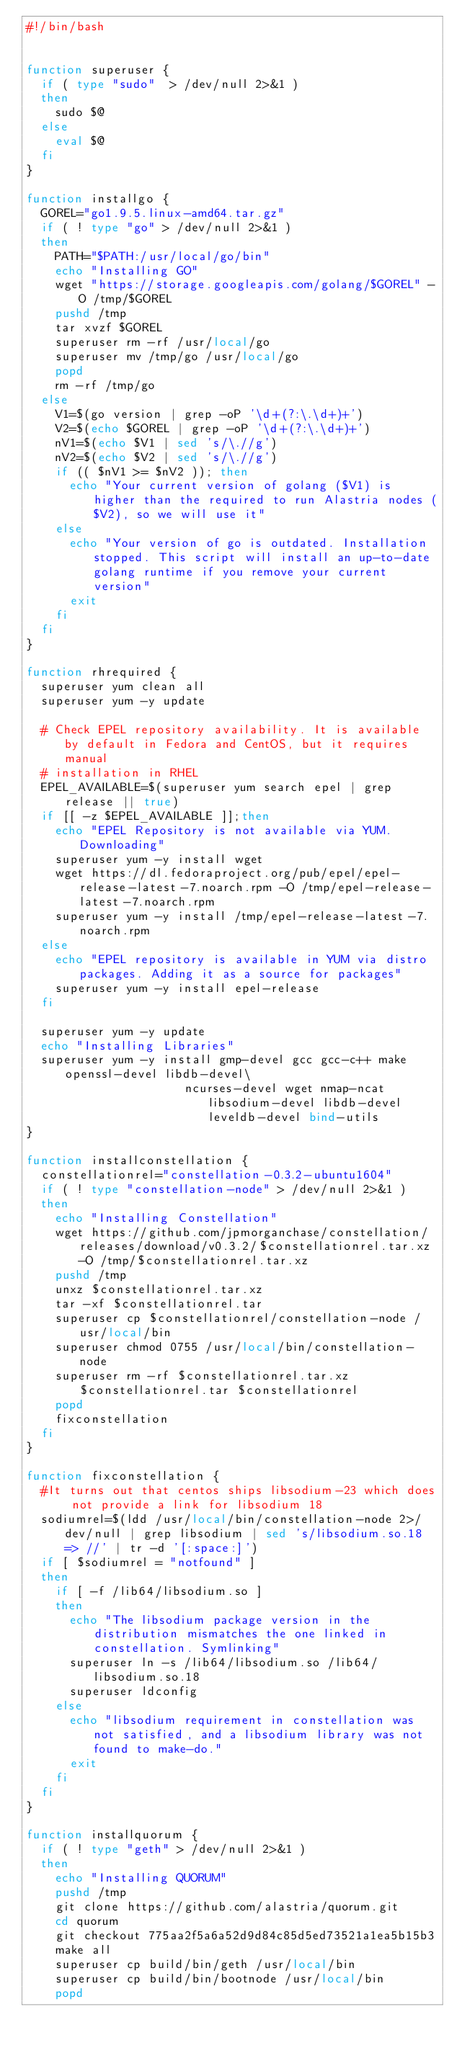<code> <loc_0><loc_0><loc_500><loc_500><_Bash_>#!/bin/bash


function superuser {
  if ( type "sudo"  > /dev/null 2>&1 )
  then
    sudo $@
  else
    eval $@
  fi
}

function installgo {
  GOREL="go1.9.5.linux-amd64.tar.gz"
  if ( ! type "go" > /dev/null 2>&1 )
  then
    PATH="$PATH:/usr/local/go/bin"
    echo "Installing GO"    
    wget "https://storage.googleapis.com/golang/$GOREL" -O /tmp/$GOREL
    pushd /tmp
    tar xvzf $GOREL
    superuser rm -rf /usr/local/go
    superuser mv /tmp/go /usr/local/go
    popd
    rm -rf /tmp/go
  else
    V1=$(go version | grep -oP '\d+(?:\.\d+)+')
    V2=$(echo $GOREL | grep -oP '\d+(?:\.\d+)+')
    nV1=$(echo $V1 | sed 's/\.//g')
    nV2=$(echo $V2 | sed 's/\.//g')
    if (( $nV1 >= $nV2 )); then
      echo "Your current version of golang ($V1) is higher than the required to run Alastria nodes ($V2), so we will use it"
    else
      echo "Your version of go is outdated. Installation stopped. This script will install an up-to-date golang runtime if you remove your current version"
      exit
    fi
  fi
}

function rhrequired {
  superuser yum clean all
  superuser yum -y update
  
  # Check EPEL repository availability. It is available by default in Fedora and CentOS, but it requires manual
  # installation in RHEL
  EPEL_AVAILABLE=$(superuser yum search epel | grep release || true)
  if [[ -z $EPEL_AVAILABLE ]];then
    echo "EPEL Repository is not available via YUM. Downloading"
    superuser yum -y install wget
    wget https://dl.fedoraproject.org/pub/epel/epel-release-latest-7.noarch.rpm -O /tmp/epel-release-latest-7.noarch.rpm
    superuser yum -y install /tmp/epel-release-latest-7.noarch.rpm
  else 
    echo "EPEL repository is available in YUM via distro packages. Adding it as a source for packages"
    superuser yum -y install epel-release
  fi
  
  superuser yum -y update
  echo "Installing Libraries"
  superuser yum -y install gmp-devel gcc gcc-c++ make openssl-devel libdb-devel\
                      ncurses-devel wget nmap-ncat libsodium-devel libdb-devel leveldb-devel bind-utils
}

function installconstellation {
  constellationrel="constellation-0.3.2-ubuntu1604"
  if ( ! type "constellation-node" > /dev/null 2>&1 )
  then
    echo "Installing Constellation"
    wget https://github.com/jpmorganchase/constellation/releases/download/v0.3.2/$constellationrel.tar.xz -O /tmp/$constellationrel.tar.xz
    pushd /tmp
    unxz $constellationrel.tar.xz
    tar -xf $constellationrel.tar
    superuser cp $constellationrel/constellation-node /usr/local/bin 
    superuser chmod 0755 /usr/local/bin/constellation-node
    superuser rm -rf $constellationrel.tar.xz $constellationrel.tar $constellationrel
    popd
    fixconstellation
  fi
}

function fixconstellation {
  #It turns out that centos ships libsodium-23 which does not provide a link for libsodium 18
  sodiumrel=$(ldd /usr/local/bin/constellation-node 2>/dev/null | grep libsodium | sed 's/libsodium.so.18 => //' | tr -d '[:space:]')
  if [ $sodiumrel = "notfound" ]
  then
    if [ -f /lib64/libsodium.so ]
    then
      echo "The libsodium package version in the distribution mismatches the one linked in constellation. Symlinking"
      superuser ln -s /lib64/libsodium.so /lib64/libsodium.so.18
      superuser ldconfig
    else
      echo "libsodium requirement in constellation was not satisfied, and a libsodium library was not found to make-do."
      exit
    fi
  fi 
}

function installquorum {
  if ( ! type "geth" > /dev/null 2>&1 )
  then
    echo "Installing QUORUM"
    pushd /tmp
    git clone https://github.com/alastria/quorum.git
    cd quorum
    git checkout 775aa2f5a6a52d9d84c85d5ed73521a1ea5b15b3
    make all
    superuser cp build/bin/geth /usr/local/bin
    superuser cp build/bin/bootnode /usr/local/bin
    popd</code> 